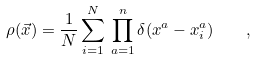<formula> <loc_0><loc_0><loc_500><loc_500>\rho ( \vec { x } ) = \frac { 1 } { N } \sum _ { i = 1 } ^ { N } \, \prod _ { a = 1 } ^ { n } \delta ( x ^ { a } - x _ { i } ^ { a } ) \quad ,</formula> 